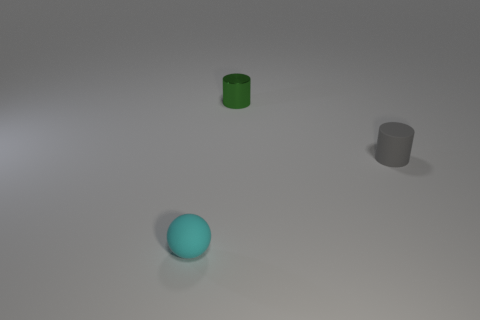There is a object that is in front of the green object and on the right side of the tiny cyan thing; what is its size?
Give a very brief answer. Small. Is the tiny object that is on the right side of the tiny green metal cylinder made of the same material as the small thing that is left of the small green shiny object?
Your answer should be compact. Yes. What is the shape of the matte thing that is the same size as the cyan matte sphere?
Keep it short and to the point. Cylinder. Is the number of gray matte cylinders less than the number of tiny cylinders?
Provide a short and direct response. Yes. There is a small matte object to the right of the ball; are there any small gray cylinders that are in front of it?
Offer a very short reply. No. Is there a rubber sphere in front of the small rubber thing in front of the cylinder that is in front of the tiny green metallic cylinder?
Provide a short and direct response. No. There is a matte thing on the left side of the tiny green metallic cylinder; does it have the same shape as the thing that is behind the tiny gray rubber thing?
Give a very brief answer. No. What color is the tiny thing that is made of the same material as the small ball?
Offer a very short reply. Gray. Are there fewer green objects on the left side of the tiny green thing than tiny metal cylinders?
Make the answer very short. Yes. There is a matte object that is behind the tiny object in front of the tiny cylinder that is on the right side of the small shiny object; what size is it?
Ensure brevity in your answer.  Small. 